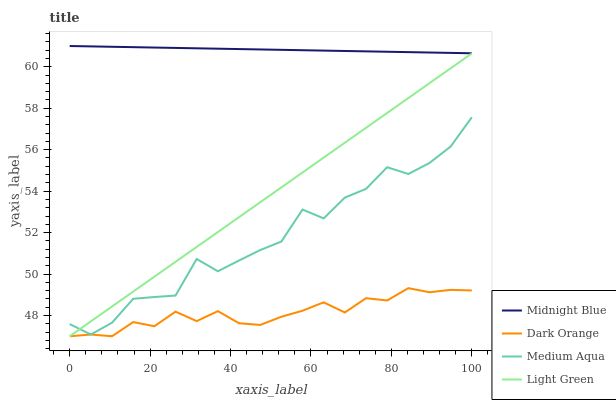Does Dark Orange have the minimum area under the curve?
Answer yes or no. Yes. Does Midnight Blue have the maximum area under the curve?
Answer yes or no. Yes. Does Medium Aqua have the minimum area under the curve?
Answer yes or no. No. Does Medium Aqua have the maximum area under the curve?
Answer yes or no. No. Is Midnight Blue the smoothest?
Answer yes or no. Yes. Is Medium Aqua the roughest?
Answer yes or no. Yes. Is Medium Aqua the smoothest?
Answer yes or no. No. Is Midnight Blue the roughest?
Answer yes or no. No. Does Dark Orange have the lowest value?
Answer yes or no. Yes. Does Medium Aqua have the lowest value?
Answer yes or no. No. Does Midnight Blue have the highest value?
Answer yes or no. Yes. Does Medium Aqua have the highest value?
Answer yes or no. No. Is Dark Orange less than Medium Aqua?
Answer yes or no. Yes. Is Midnight Blue greater than Dark Orange?
Answer yes or no. Yes. Does Light Green intersect Medium Aqua?
Answer yes or no. Yes. Is Light Green less than Medium Aqua?
Answer yes or no. No. Is Light Green greater than Medium Aqua?
Answer yes or no. No. Does Dark Orange intersect Medium Aqua?
Answer yes or no. No. 